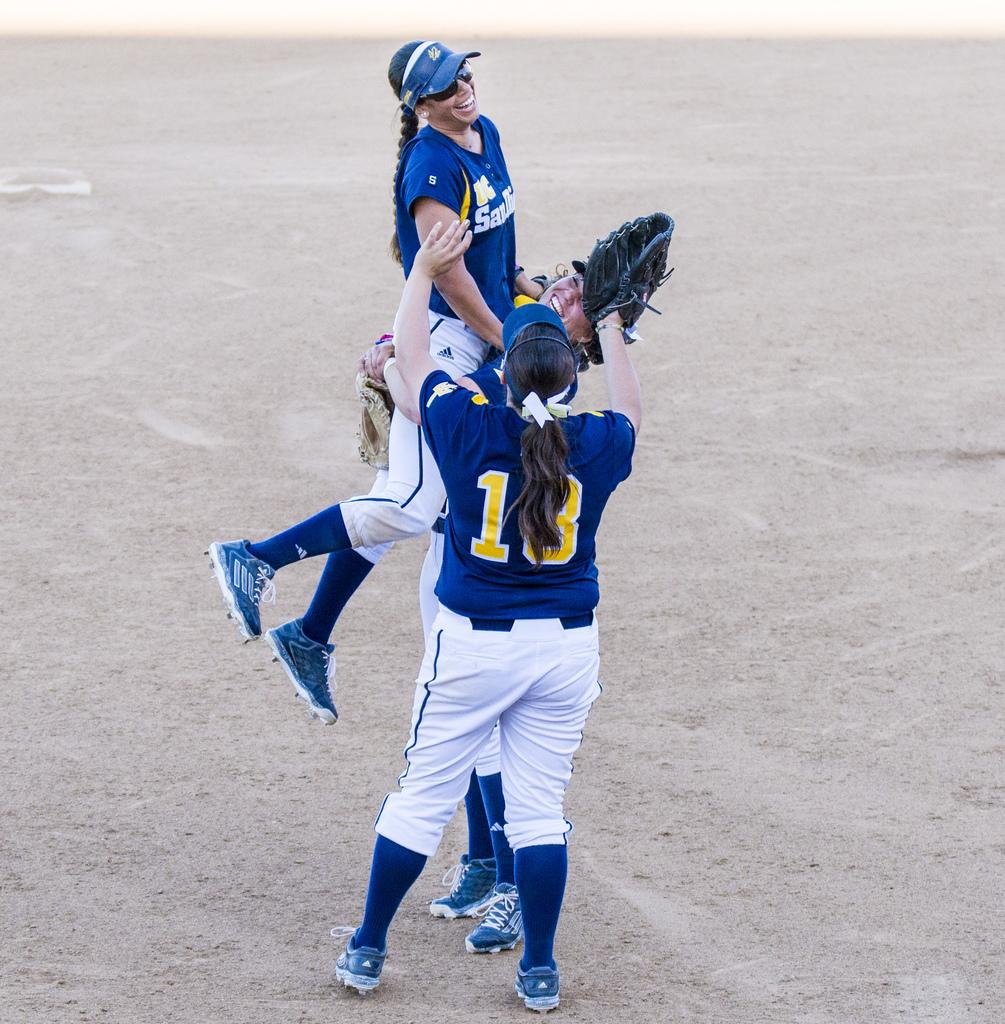<image>
Share a concise interpretation of the image provided. Two female softball players from UC San Diego are lifting a third player. 